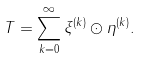Convert formula to latex. <formula><loc_0><loc_0><loc_500><loc_500>T = \sum _ { k = 0 } ^ { \infty } \xi ^ { ( k ) } \odot \eta ^ { ( k ) } .</formula> 